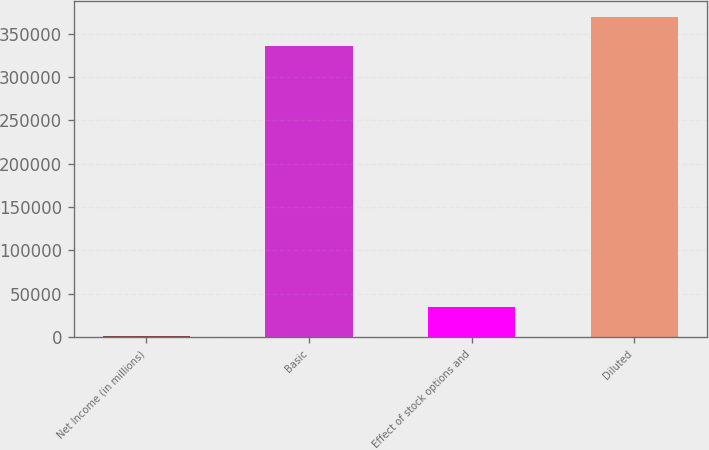<chart> <loc_0><loc_0><loc_500><loc_500><bar_chart><fcel>Net Income (in millions)<fcel>Basic<fcel>Effect of stock options and<fcel>Diluted<nl><fcel>1247<fcel>336224<fcel>34911.7<fcel>369889<nl></chart> 